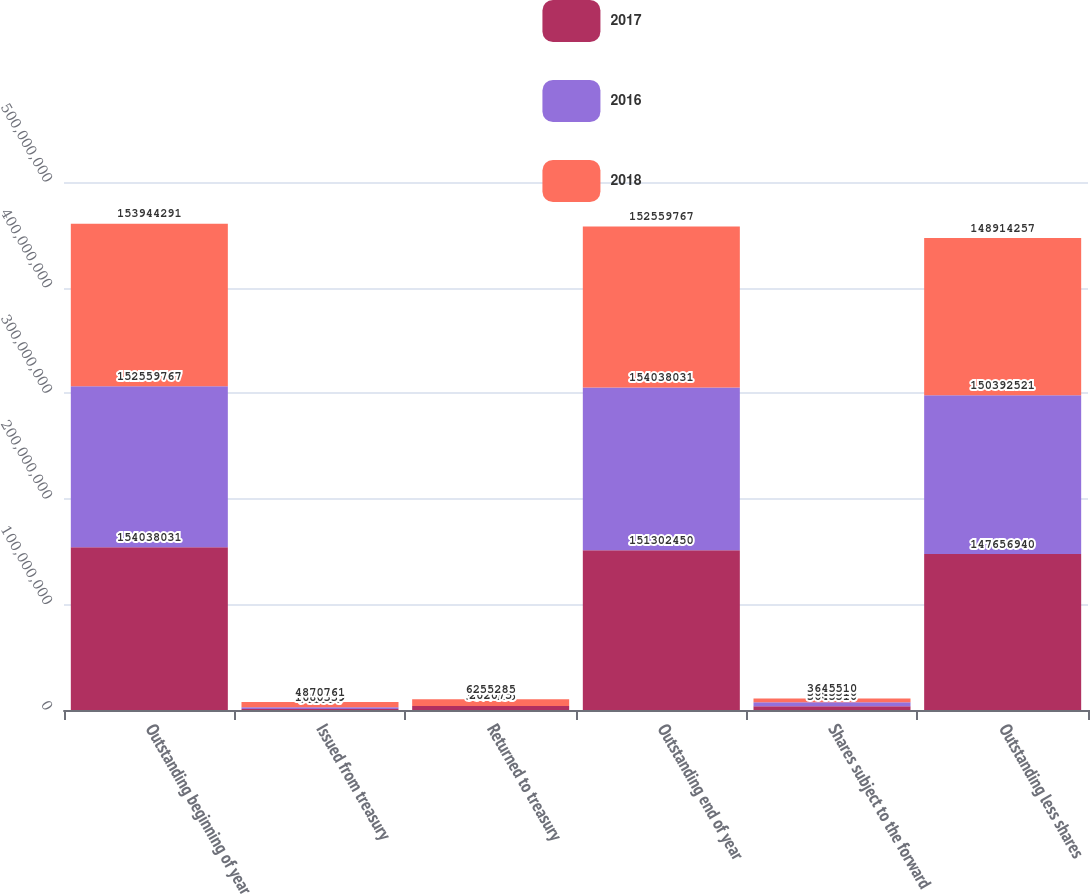Convert chart. <chart><loc_0><loc_0><loc_500><loc_500><stacked_bar_chart><ecel><fcel>Outstanding beginning of year<fcel>Issued from treasury<fcel>Returned to treasury<fcel>Outstanding end of year<fcel>Shares subject to the forward<fcel>Outstanding less shares<nl><fcel>2017<fcel>1.54038e+08<fcel>941854<fcel>3.67744e+06<fcel>1.51302e+08<fcel>3.64551e+06<fcel>1.47657e+08<nl><fcel>2016<fcel>1.5256e+08<fcel>1.68034e+06<fcel>202075<fcel>1.54038e+08<fcel>3.64551e+06<fcel>1.50393e+08<nl><fcel>2018<fcel>1.53944e+08<fcel>4.87076e+06<fcel>6.25528e+06<fcel>1.5256e+08<fcel>3.64551e+06<fcel>1.48914e+08<nl></chart> 